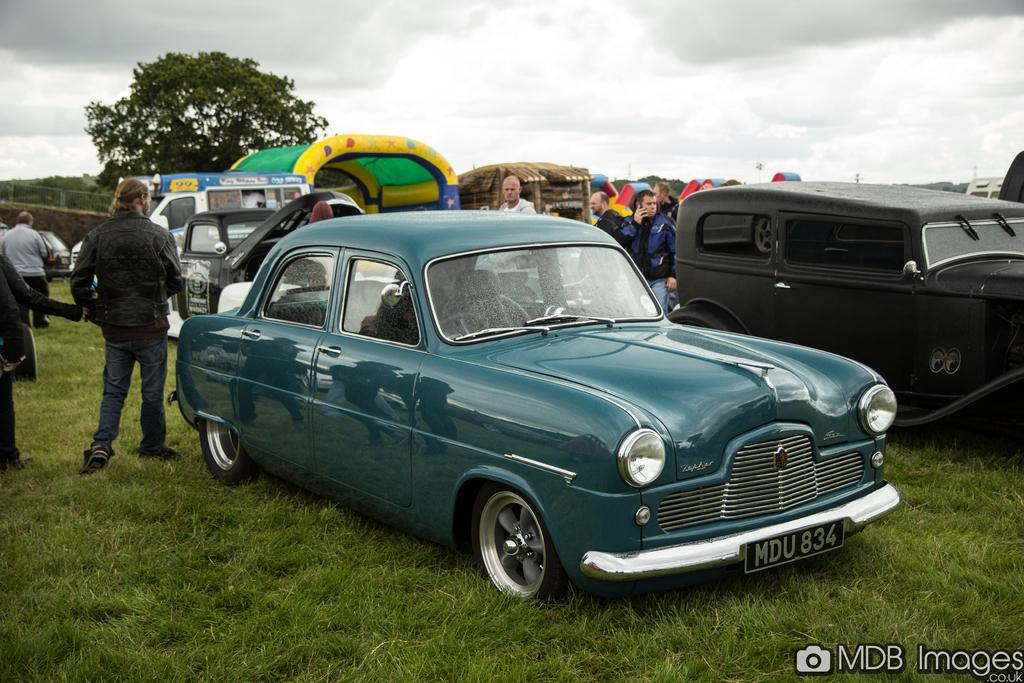<image>
Summarize the visual content of the image. A turquoise car is parked, with a license plate reading "MDU834." 